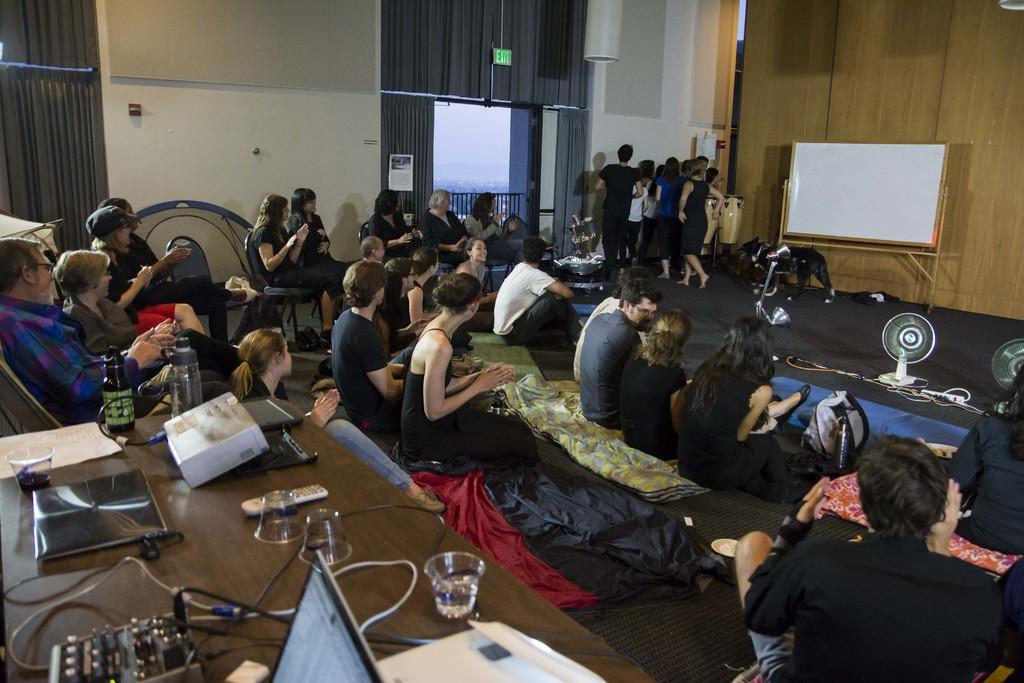Who is present in the image? There are people in the image. What are the people doing in the image? The people are watching a performance. Who is involved in the performance? There are performers in the image. What type of cloth is being used to make the throne in the image? There is no throne present in the image. 